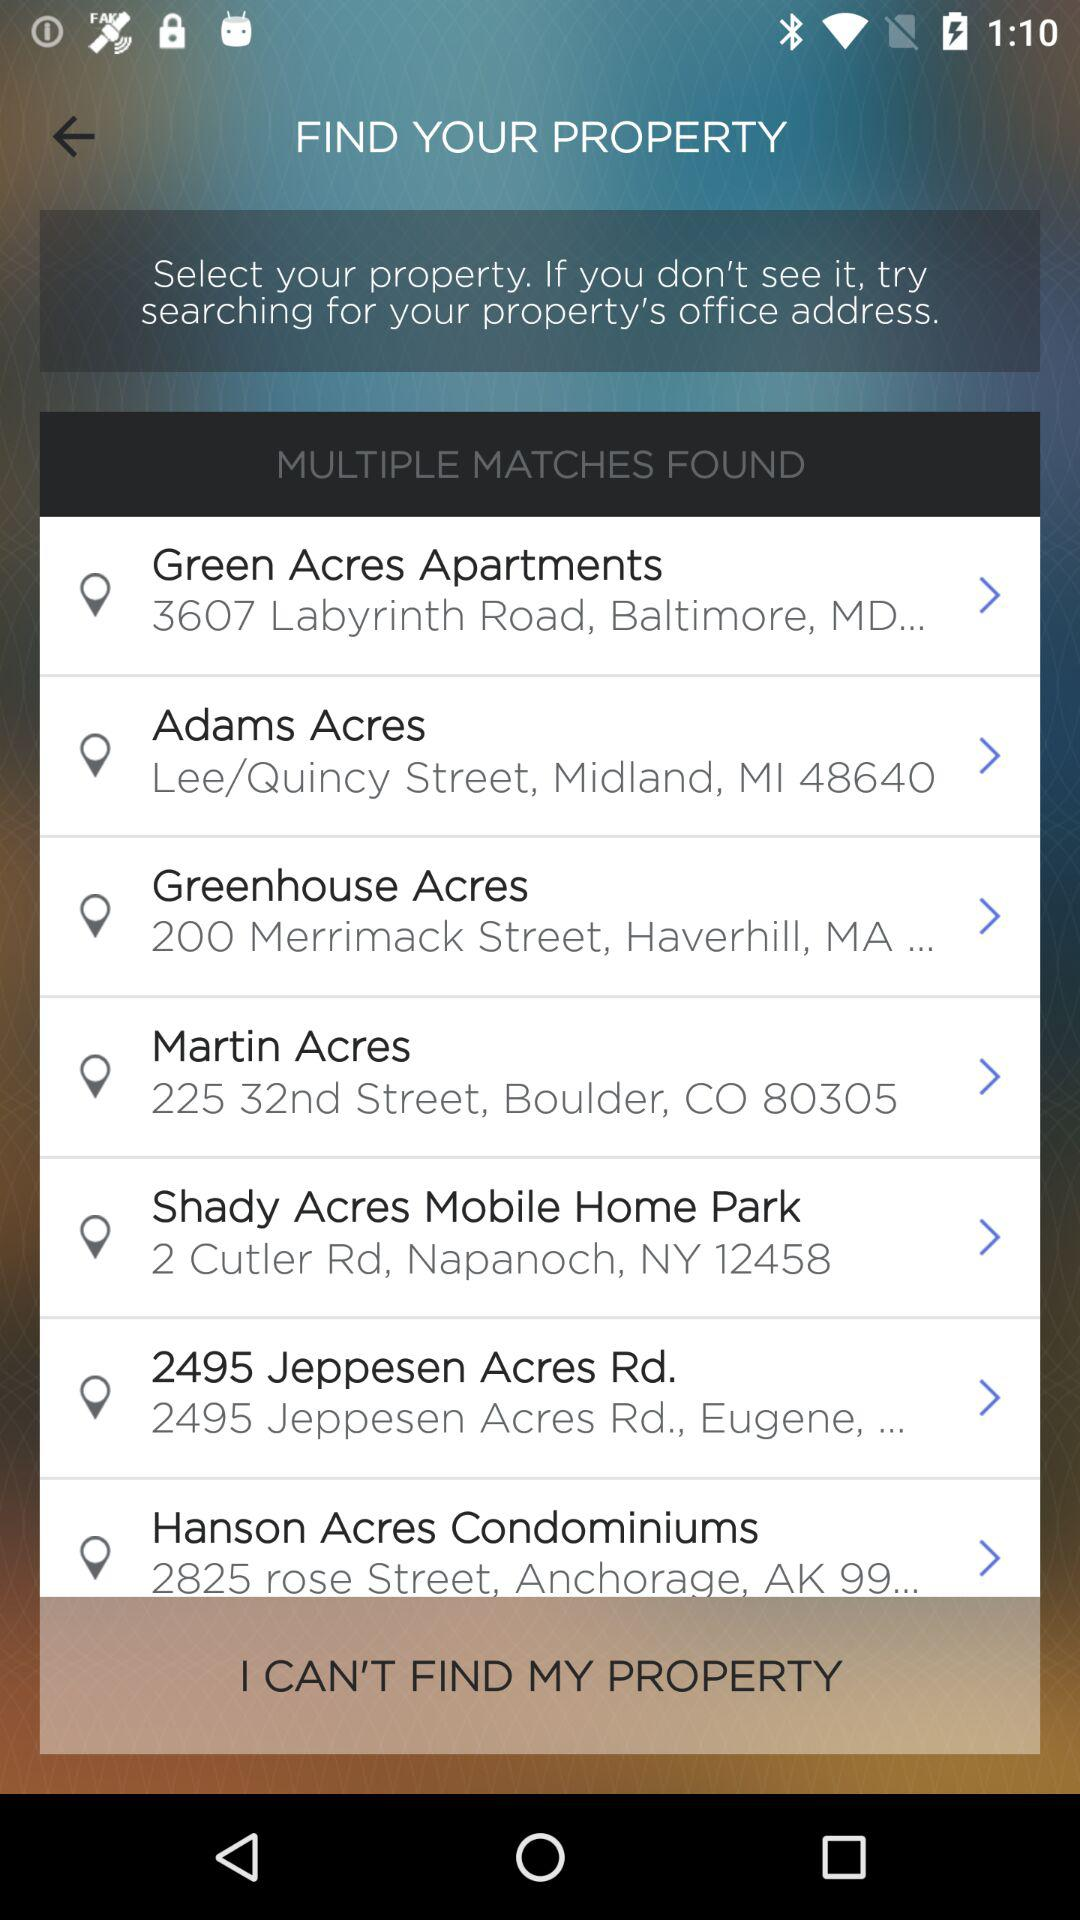To which city does the zip code 48640 belong? The zip code 48640 belongs to Midland. 